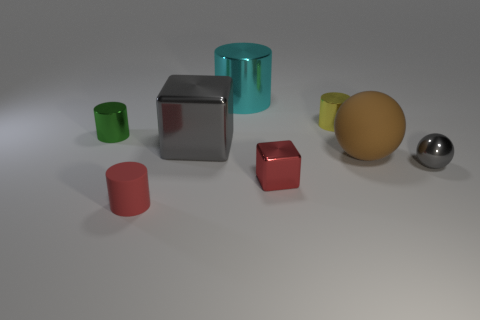There is a tiny object left of the matte cylinder; is it the same color as the tiny metallic sphere?
Offer a very short reply. No. What shape is the gray thing that is behind the ball that is to the right of the large matte object?
Your answer should be very brief. Cube. Is there a gray thing that has the same size as the yellow thing?
Your response must be concise. Yes. Are there fewer large metal cubes than small brown matte spheres?
Offer a terse response. No. There is a small red object that is in front of the red thing on the right side of the cylinder that is in front of the green metallic cylinder; what is its shape?
Provide a succinct answer. Cylinder. What number of objects are cylinders behind the small green cylinder or red objects to the right of the big cyan thing?
Your answer should be very brief. 3. Are there any big objects left of the brown ball?
Give a very brief answer. Yes. How many objects are either small metal objects behind the tiny gray object or rubber objects?
Ensure brevity in your answer.  4. What number of green things are small matte objects or shiny spheres?
Your response must be concise. 0. How many other objects are there of the same color as the large shiny block?
Your response must be concise. 1. 